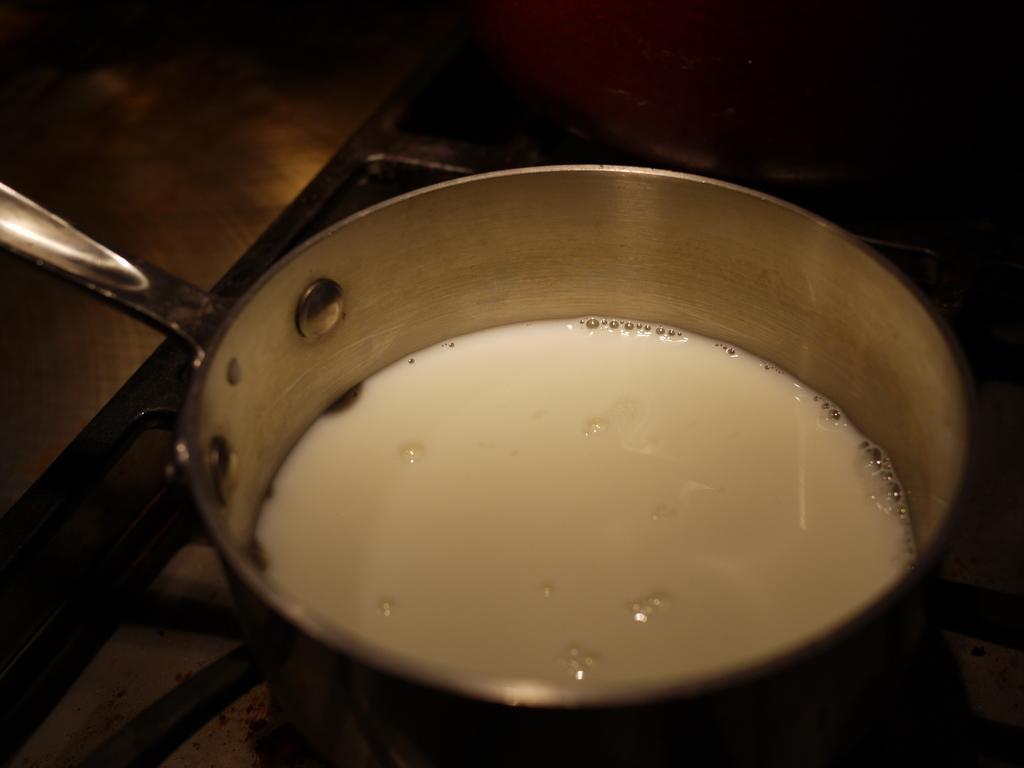Please provide a concise description of this image. In this picture we can see a milk on a cooking pan. This cooking pan is on the grill. We can see a cooking vessel on the grill on top of the image. 